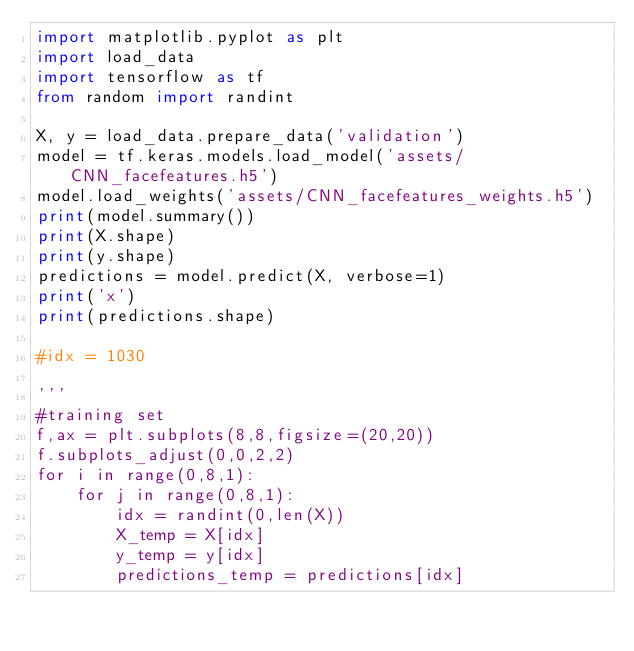<code> <loc_0><loc_0><loc_500><loc_500><_Python_>import matplotlib.pyplot as plt
import load_data
import tensorflow as tf
from random import randint

X, y = load_data.prepare_data('validation')
model = tf.keras.models.load_model('assets/CNN_facefeatures.h5')
model.load_weights('assets/CNN_facefeatures_weights.h5')
print(model.summary())
print(X.shape)
print(y.shape)
predictions = model.predict(X, verbose=1)
print('x')
print(predictions.shape)

#idx = 1030

'''
#training set
f,ax = plt.subplots(8,8,figsize=(20,20))
f.subplots_adjust(0,0,2,2)
for i in range(0,8,1):
    for j in range(0,8,1):
        idx = randint(0,len(X))
        X_temp = X[idx]
        y_temp = y[idx]
        predictions_temp = predictions[idx]</code> 